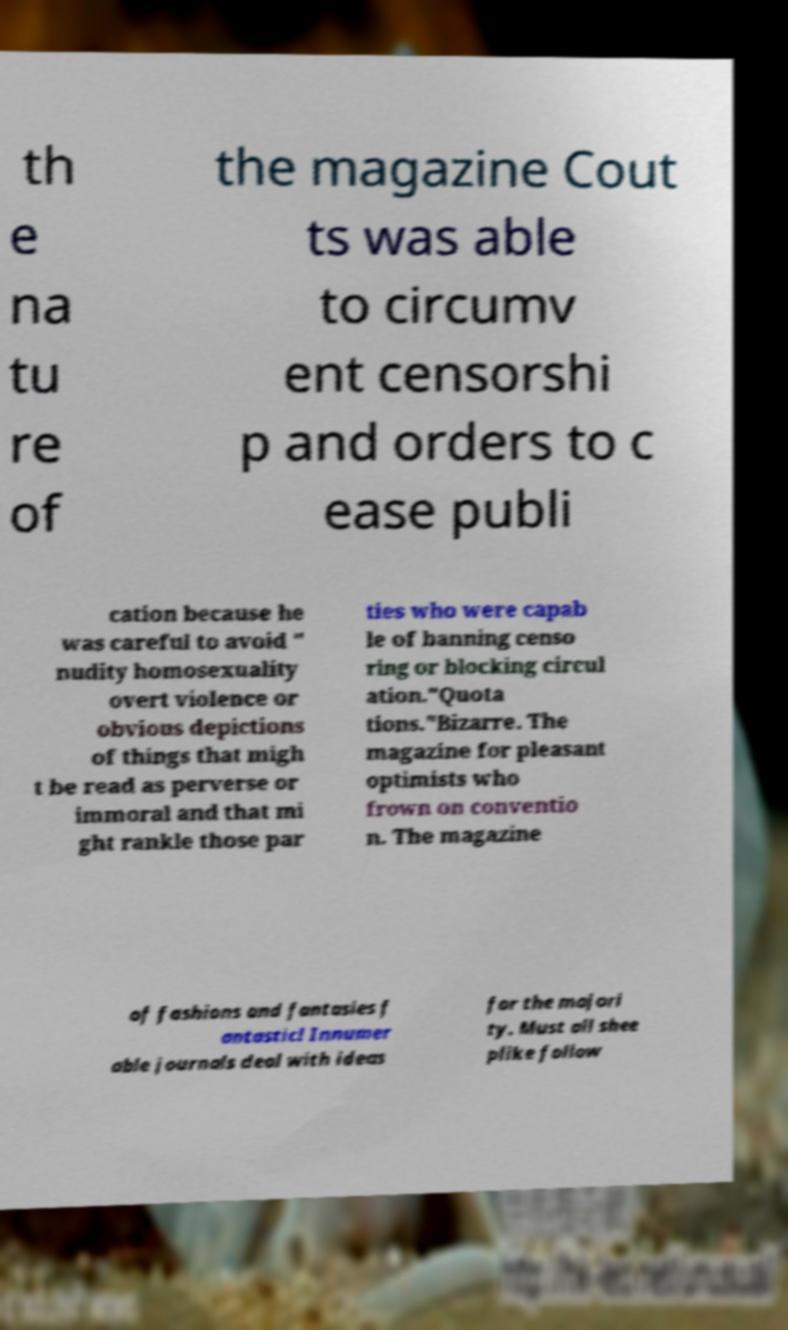Can you read and provide the text displayed in the image?This photo seems to have some interesting text. Can you extract and type it out for me? th e na tu re of the magazine Cout ts was able to circumv ent censorshi p and orders to c ease publi cation because he was careful to avoid " nudity homosexuality overt violence or obvious depictions of things that migh t be read as perverse or immoral and that mi ght rankle those par ties who were capab le of banning censo ring or blocking circul ation."Quota tions."Bizarre. The magazine for pleasant optimists who frown on conventio n. The magazine of fashions and fantasies f antastic! Innumer able journals deal with ideas for the majori ty. Must all shee plike follow 